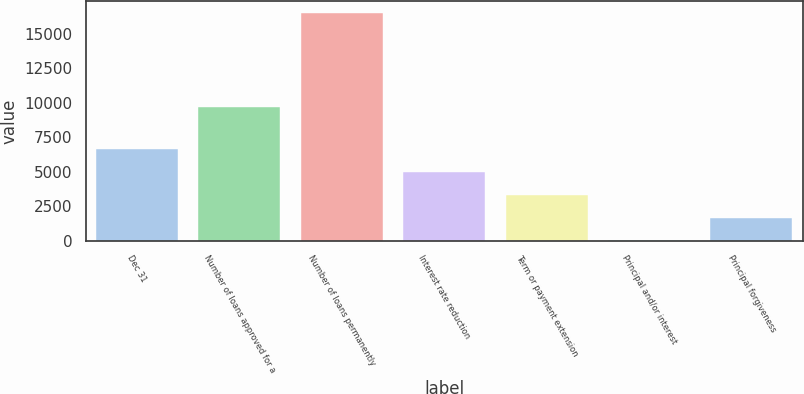<chart> <loc_0><loc_0><loc_500><loc_500><bar_chart><fcel>Dec 31<fcel>Number of loans approved for a<fcel>Number of loans permanently<fcel>Interest rate reduction<fcel>Term or payment extension<fcel>Principal and/or interest<fcel>Principal forgiveness<nl><fcel>6622.6<fcel>9682<fcel>16525<fcel>4972.2<fcel>3321.8<fcel>21<fcel>1671.4<nl></chart> 